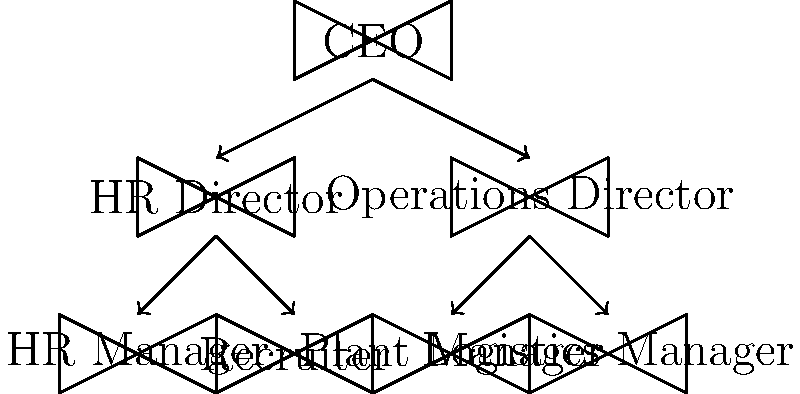Based on the organizational chart, if an HR Manager wants to propose a new company-wide recruitment policy, how many levels of approval would be required before reaching the CEO? To determine the number of approval levels required for the HR Manager's proposal to reach the CEO, we need to trace the reporting structure from the HR Manager to the CEO:

1. First, we identify the HR Manager's position in the chart (bottom left).
2. We see that the HR Manager reports directly to the HR Director.
3. The HR Director, in turn, reports to the CEO.

Therefore, the path from the HR Manager to the CEO involves two steps:
1. HR Manager → HR Director
2. HR Director → CEO

Each of these steps represents a level of approval required. The HR Manager would first need approval from the HR Director, and then the HR Director would need approval from the CEO.
Answer: 2 levels 